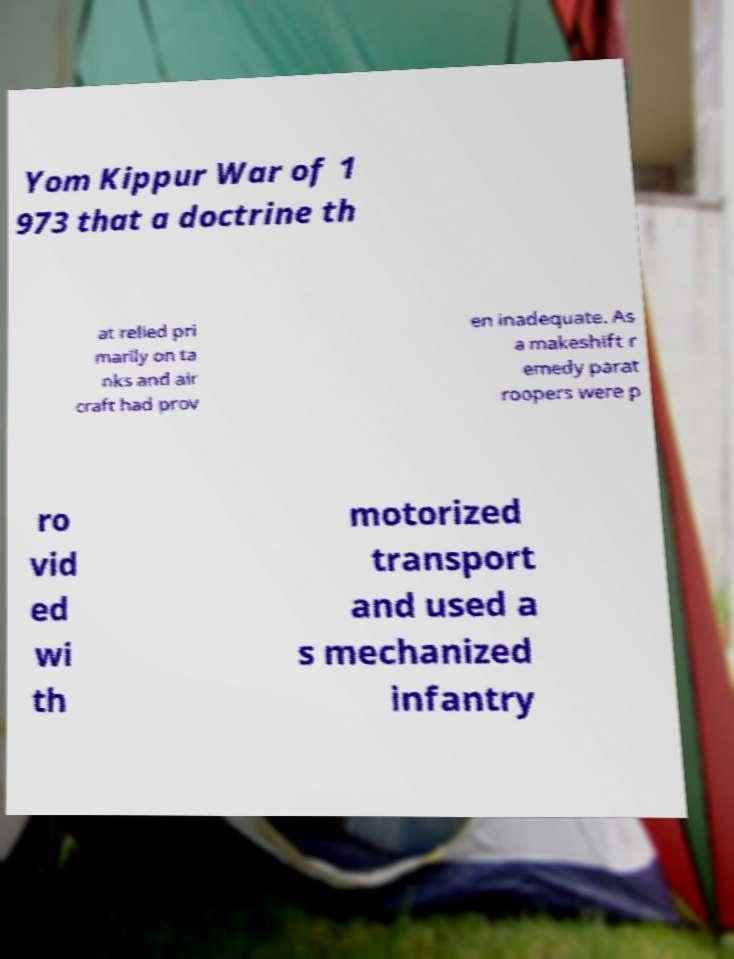Please identify and transcribe the text found in this image. Yom Kippur War of 1 973 that a doctrine th at relied pri marily on ta nks and air craft had prov en inadequate. As a makeshift r emedy parat roopers were p ro vid ed wi th motorized transport and used a s mechanized infantry 